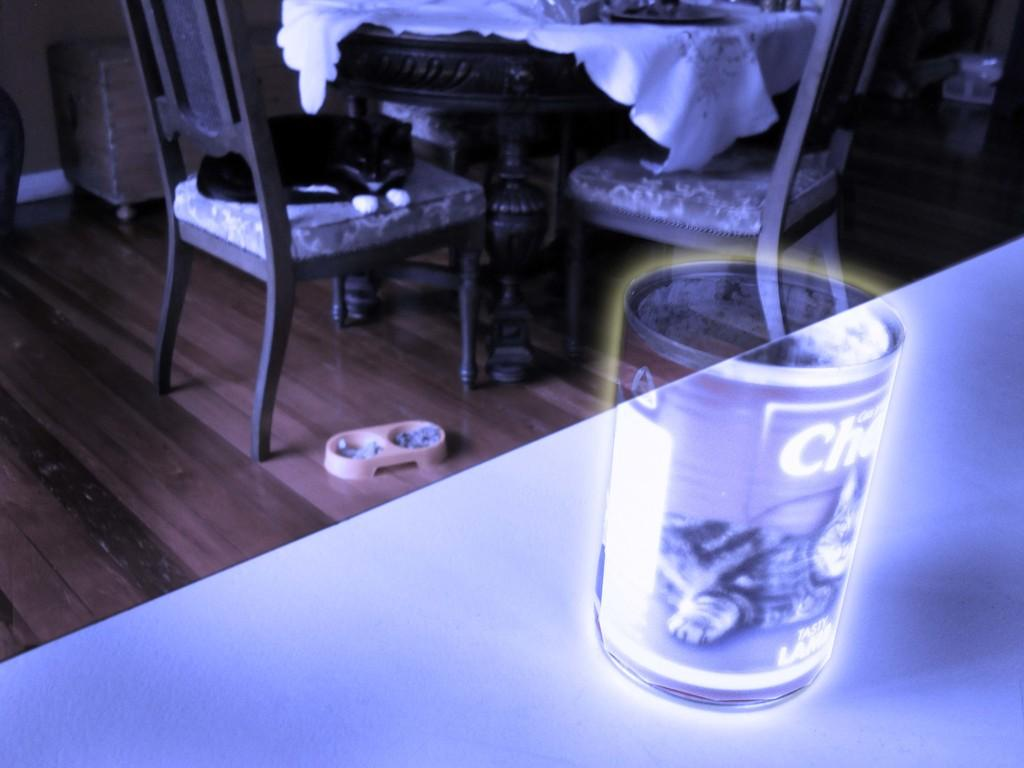What type of furniture is present in the image? There is a table and chairs in the image. What is the cat doing in the image? The cat is sitting on one of the chairs. What can be found in the center of the image? There is a container in the middle of the image. What type of butter is being used to expand the container in the image? There is no butter or expansion mentioned in the image; it only features a table, chairs, a cat, and a container. 